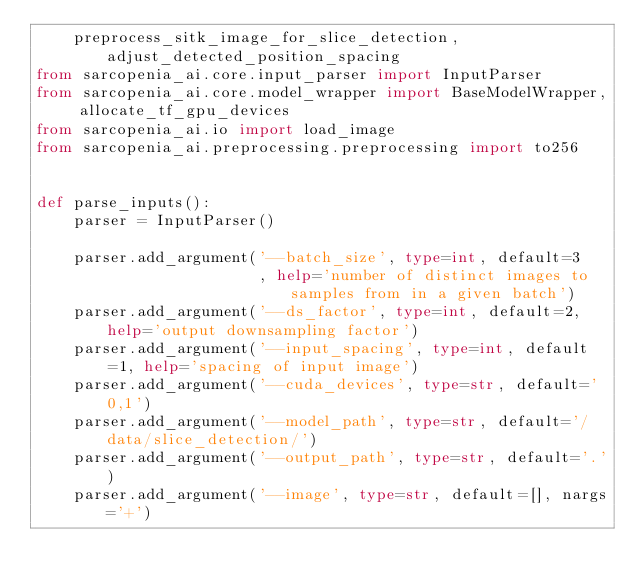Convert code to text. <code><loc_0><loc_0><loc_500><loc_500><_Python_>    preprocess_sitk_image_for_slice_detection, adjust_detected_position_spacing
from sarcopenia_ai.core.input_parser import InputParser
from sarcopenia_ai.core.model_wrapper import BaseModelWrapper, allocate_tf_gpu_devices
from sarcopenia_ai.io import load_image
from sarcopenia_ai.preprocessing.preprocessing import to256


def parse_inputs():
    parser = InputParser()

    parser.add_argument('--batch_size', type=int, default=3
                        , help='number of distinct images to samples from in a given batch')
    parser.add_argument('--ds_factor', type=int, default=2, help='output downsampling factor')
    parser.add_argument('--input_spacing', type=int, default=1, help='spacing of input image')
    parser.add_argument('--cuda_devices', type=str, default='0,1')
    parser.add_argument('--model_path', type=str, default='/data/slice_detection/')
    parser.add_argument('--output_path', type=str, default='.')
    parser.add_argument('--image', type=str, default=[], nargs='+')</code> 